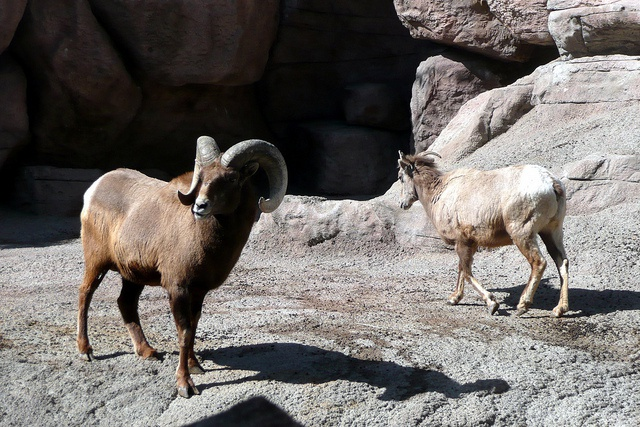Describe the objects in this image and their specific colors. I can see sheep in black, darkgray, and tan tones and sheep in black, lightgray, gray, and darkgray tones in this image. 